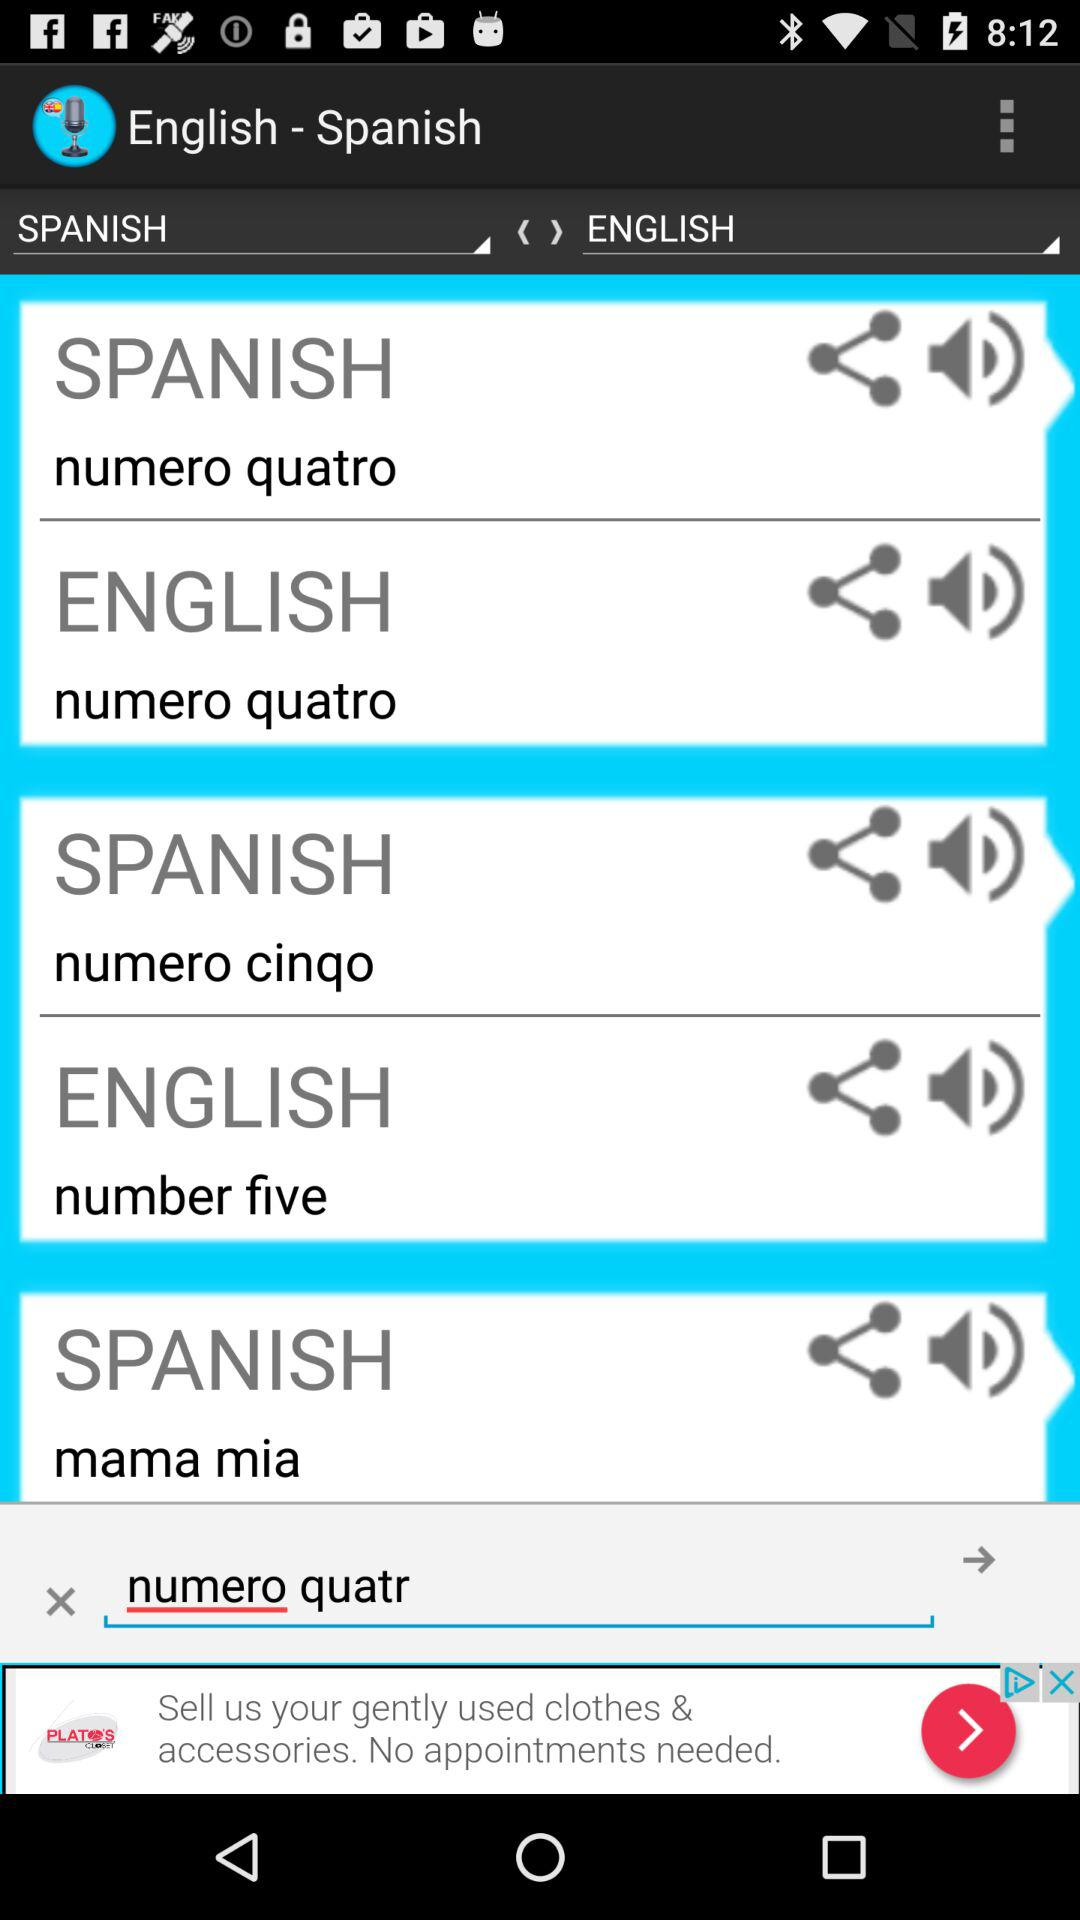What is written in the search field? In the search field, "numero quatr" is written. 